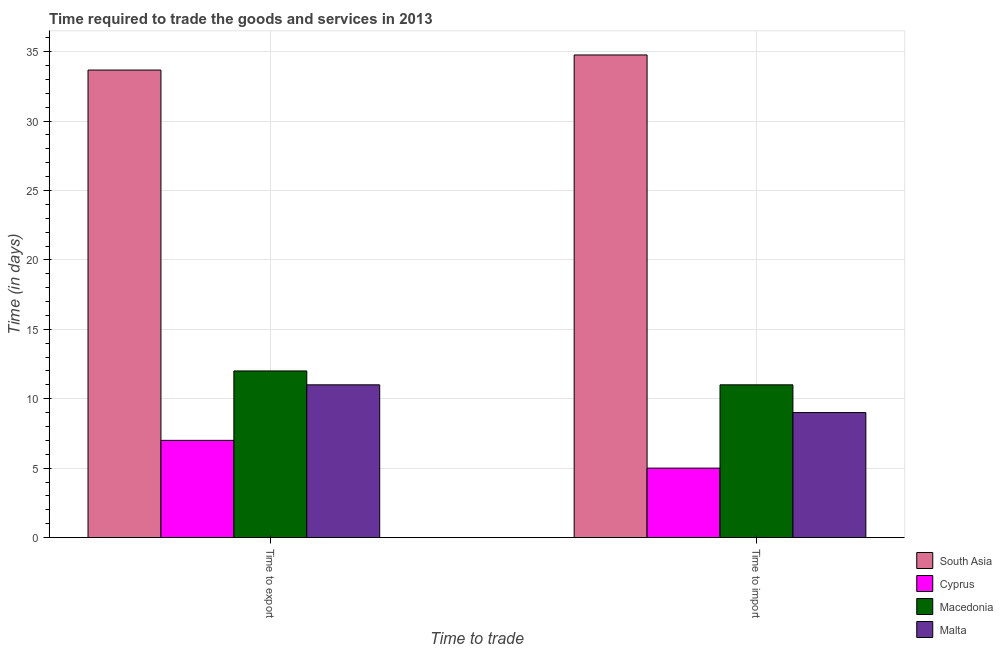How many different coloured bars are there?
Provide a short and direct response. 4. How many groups of bars are there?
Keep it short and to the point. 2. Are the number of bars per tick equal to the number of legend labels?
Make the answer very short. Yes. How many bars are there on the 1st tick from the left?
Your answer should be compact. 4. What is the label of the 2nd group of bars from the left?
Offer a terse response. Time to import. What is the time to export in Macedonia?
Offer a terse response. 12. Across all countries, what is the maximum time to import?
Make the answer very short. 34.76. Across all countries, what is the minimum time to export?
Offer a terse response. 7. In which country was the time to export maximum?
Give a very brief answer. South Asia. In which country was the time to export minimum?
Keep it short and to the point. Cyprus. What is the total time to export in the graph?
Your answer should be very brief. 63.67. What is the difference between the time to export in South Asia and that in Cyprus?
Your response must be concise. 26.67. What is the average time to export per country?
Your answer should be compact. 15.92. What is the ratio of the time to import in Cyprus to that in Macedonia?
Keep it short and to the point. 0.45. Is the time to import in Cyprus less than that in South Asia?
Provide a short and direct response. Yes. In how many countries, is the time to export greater than the average time to export taken over all countries?
Offer a terse response. 1. What does the 1st bar from the left in Time to import represents?
Provide a short and direct response. South Asia. What does the 1st bar from the right in Time to export represents?
Keep it short and to the point. Malta. How many countries are there in the graph?
Your answer should be compact. 4. What is the difference between two consecutive major ticks on the Y-axis?
Give a very brief answer. 5. Where does the legend appear in the graph?
Keep it short and to the point. Bottom right. What is the title of the graph?
Keep it short and to the point. Time required to trade the goods and services in 2013. What is the label or title of the X-axis?
Provide a succinct answer. Time to trade. What is the label or title of the Y-axis?
Your response must be concise. Time (in days). What is the Time (in days) of South Asia in Time to export?
Offer a very short reply. 33.67. What is the Time (in days) in Cyprus in Time to export?
Give a very brief answer. 7. What is the Time (in days) of Malta in Time to export?
Give a very brief answer. 11. What is the Time (in days) in South Asia in Time to import?
Your response must be concise. 34.76. What is the Time (in days) in Malta in Time to import?
Your response must be concise. 9. Across all Time to trade, what is the maximum Time (in days) of South Asia?
Your answer should be very brief. 34.76. Across all Time to trade, what is the maximum Time (in days) of Malta?
Ensure brevity in your answer.  11. Across all Time to trade, what is the minimum Time (in days) in South Asia?
Make the answer very short. 33.67. Across all Time to trade, what is the minimum Time (in days) in Cyprus?
Your answer should be compact. 5. Across all Time to trade, what is the minimum Time (in days) in Macedonia?
Offer a terse response. 11. What is the total Time (in days) in South Asia in the graph?
Keep it short and to the point. 68.44. What is the total Time (in days) in Cyprus in the graph?
Give a very brief answer. 12. What is the difference between the Time (in days) in South Asia in Time to export and that in Time to import?
Keep it short and to the point. -1.09. What is the difference between the Time (in days) in Malta in Time to export and that in Time to import?
Provide a succinct answer. 2. What is the difference between the Time (in days) of South Asia in Time to export and the Time (in days) of Cyprus in Time to import?
Give a very brief answer. 28.68. What is the difference between the Time (in days) in South Asia in Time to export and the Time (in days) in Macedonia in Time to import?
Your answer should be compact. 22.68. What is the difference between the Time (in days) of South Asia in Time to export and the Time (in days) of Malta in Time to import?
Provide a short and direct response. 24.68. What is the difference between the Time (in days) in Cyprus in Time to export and the Time (in days) in Macedonia in Time to import?
Your response must be concise. -4. What is the difference between the Time (in days) in Cyprus in Time to export and the Time (in days) in Malta in Time to import?
Make the answer very short. -2. What is the difference between the Time (in days) of Macedonia in Time to export and the Time (in days) of Malta in Time to import?
Offer a very short reply. 3. What is the average Time (in days) of South Asia per Time to trade?
Offer a very short reply. 34.22. What is the average Time (in days) of Macedonia per Time to trade?
Keep it short and to the point. 11.5. What is the difference between the Time (in days) in South Asia and Time (in days) in Cyprus in Time to export?
Provide a short and direct response. 26.68. What is the difference between the Time (in days) in South Asia and Time (in days) in Macedonia in Time to export?
Your response must be concise. 21.68. What is the difference between the Time (in days) of South Asia and Time (in days) of Malta in Time to export?
Give a very brief answer. 22.68. What is the difference between the Time (in days) in Cyprus and Time (in days) in Malta in Time to export?
Your answer should be compact. -4. What is the difference between the Time (in days) in South Asia and Time (in days) in Cyprus in Time to import?
Your answer should be very brief. 29.76. What is the difference between the Time (in days) in South Asia and Time (in days) in Macedonia in Time to import?
Keep it short and to the point. 23.76. What is the difference between the Time (in days) in South Asia and Time (in days) in Malta in Time to import?
Keep it short and to the point. 25.76. What is the ratio of the Time (in days) in South Asia in Time to export to that in Time to import?
Provide a succinct answer. 0.97. What is the ratio of the Time (in days) in Cyprus in Time to export to that in Time to import?
Your answer should be compact. 1.4. What is the ratio of the Time (in days) in Malta in Time to export to that in Time to import?
Ensure brevity in your answer.  1.22. What is the difference between the highest and the second highest Time (in days) in South Asia?
Your response must be concise. 1.09. What is the difference between the highest and the lowest Time (in days) in South Asia?
Provide a succinct answer. 1.09. 